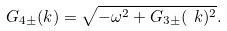Convert formula to latex. <formula><loc_0><loc_0><loc_500><loc_500>G _ { 4 \pm } ( k ) = \sqrt { - \omega ^ { 2 } + G _ { 3 \pm } ( \ k ) ^ { 2 } } .</formula> 